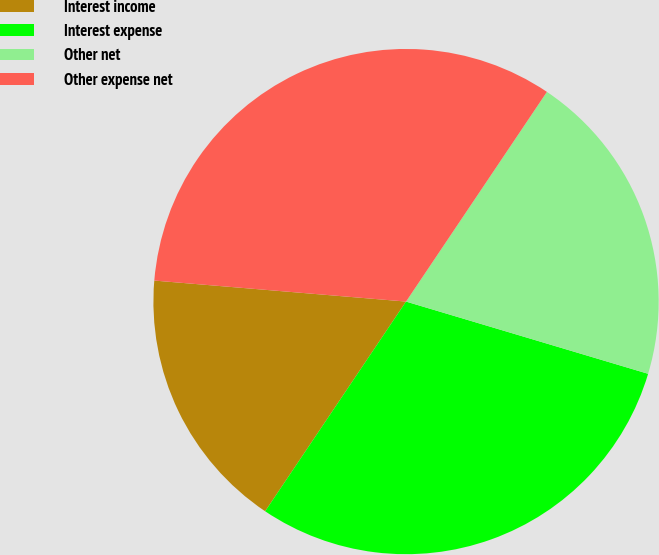<chart> <loc_0><loc_0><loc_500><loc_500><pie_chart><fcel>Interest income<fcel>Interest expense<fcel>Other net<fcel>Other expense net<nl><fcel>16.91%<fcel>29.8%<fcel>20.2%<fcel>33.09%<nl></chart> 